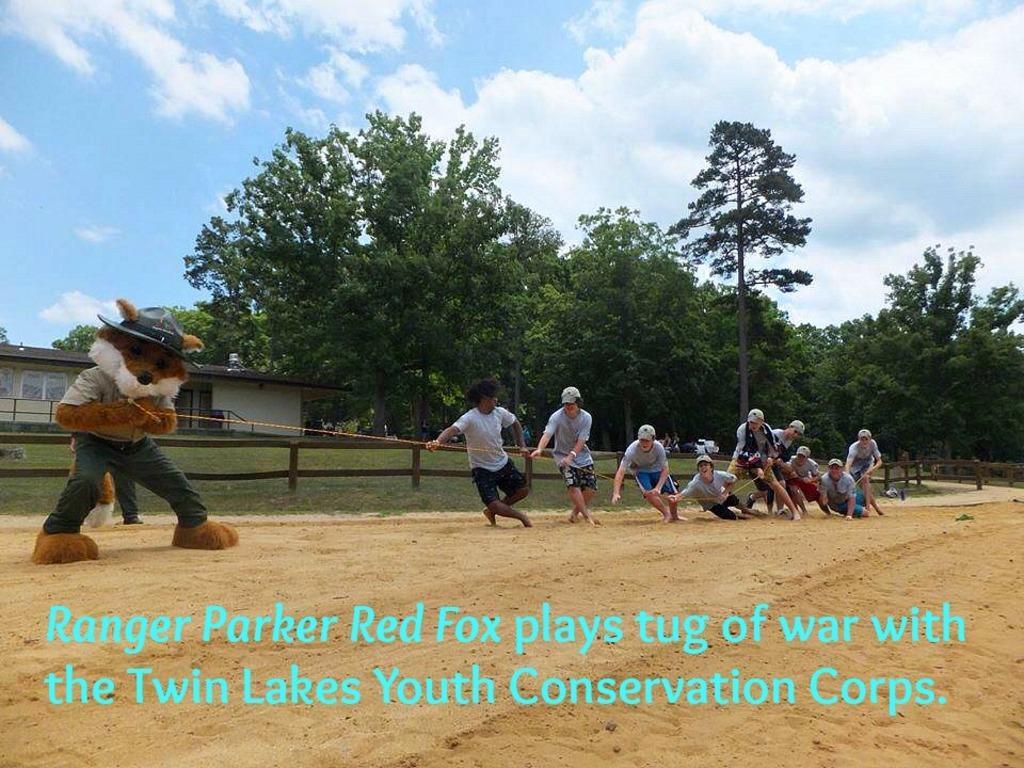Can you describe this image briefly? In this picture I see number of people who are holding the rope and on the left side of this image I see a person who is wearing a costume and I see the watermark on the bottom of this image and in the background I see a building, number of trees and the sky. 